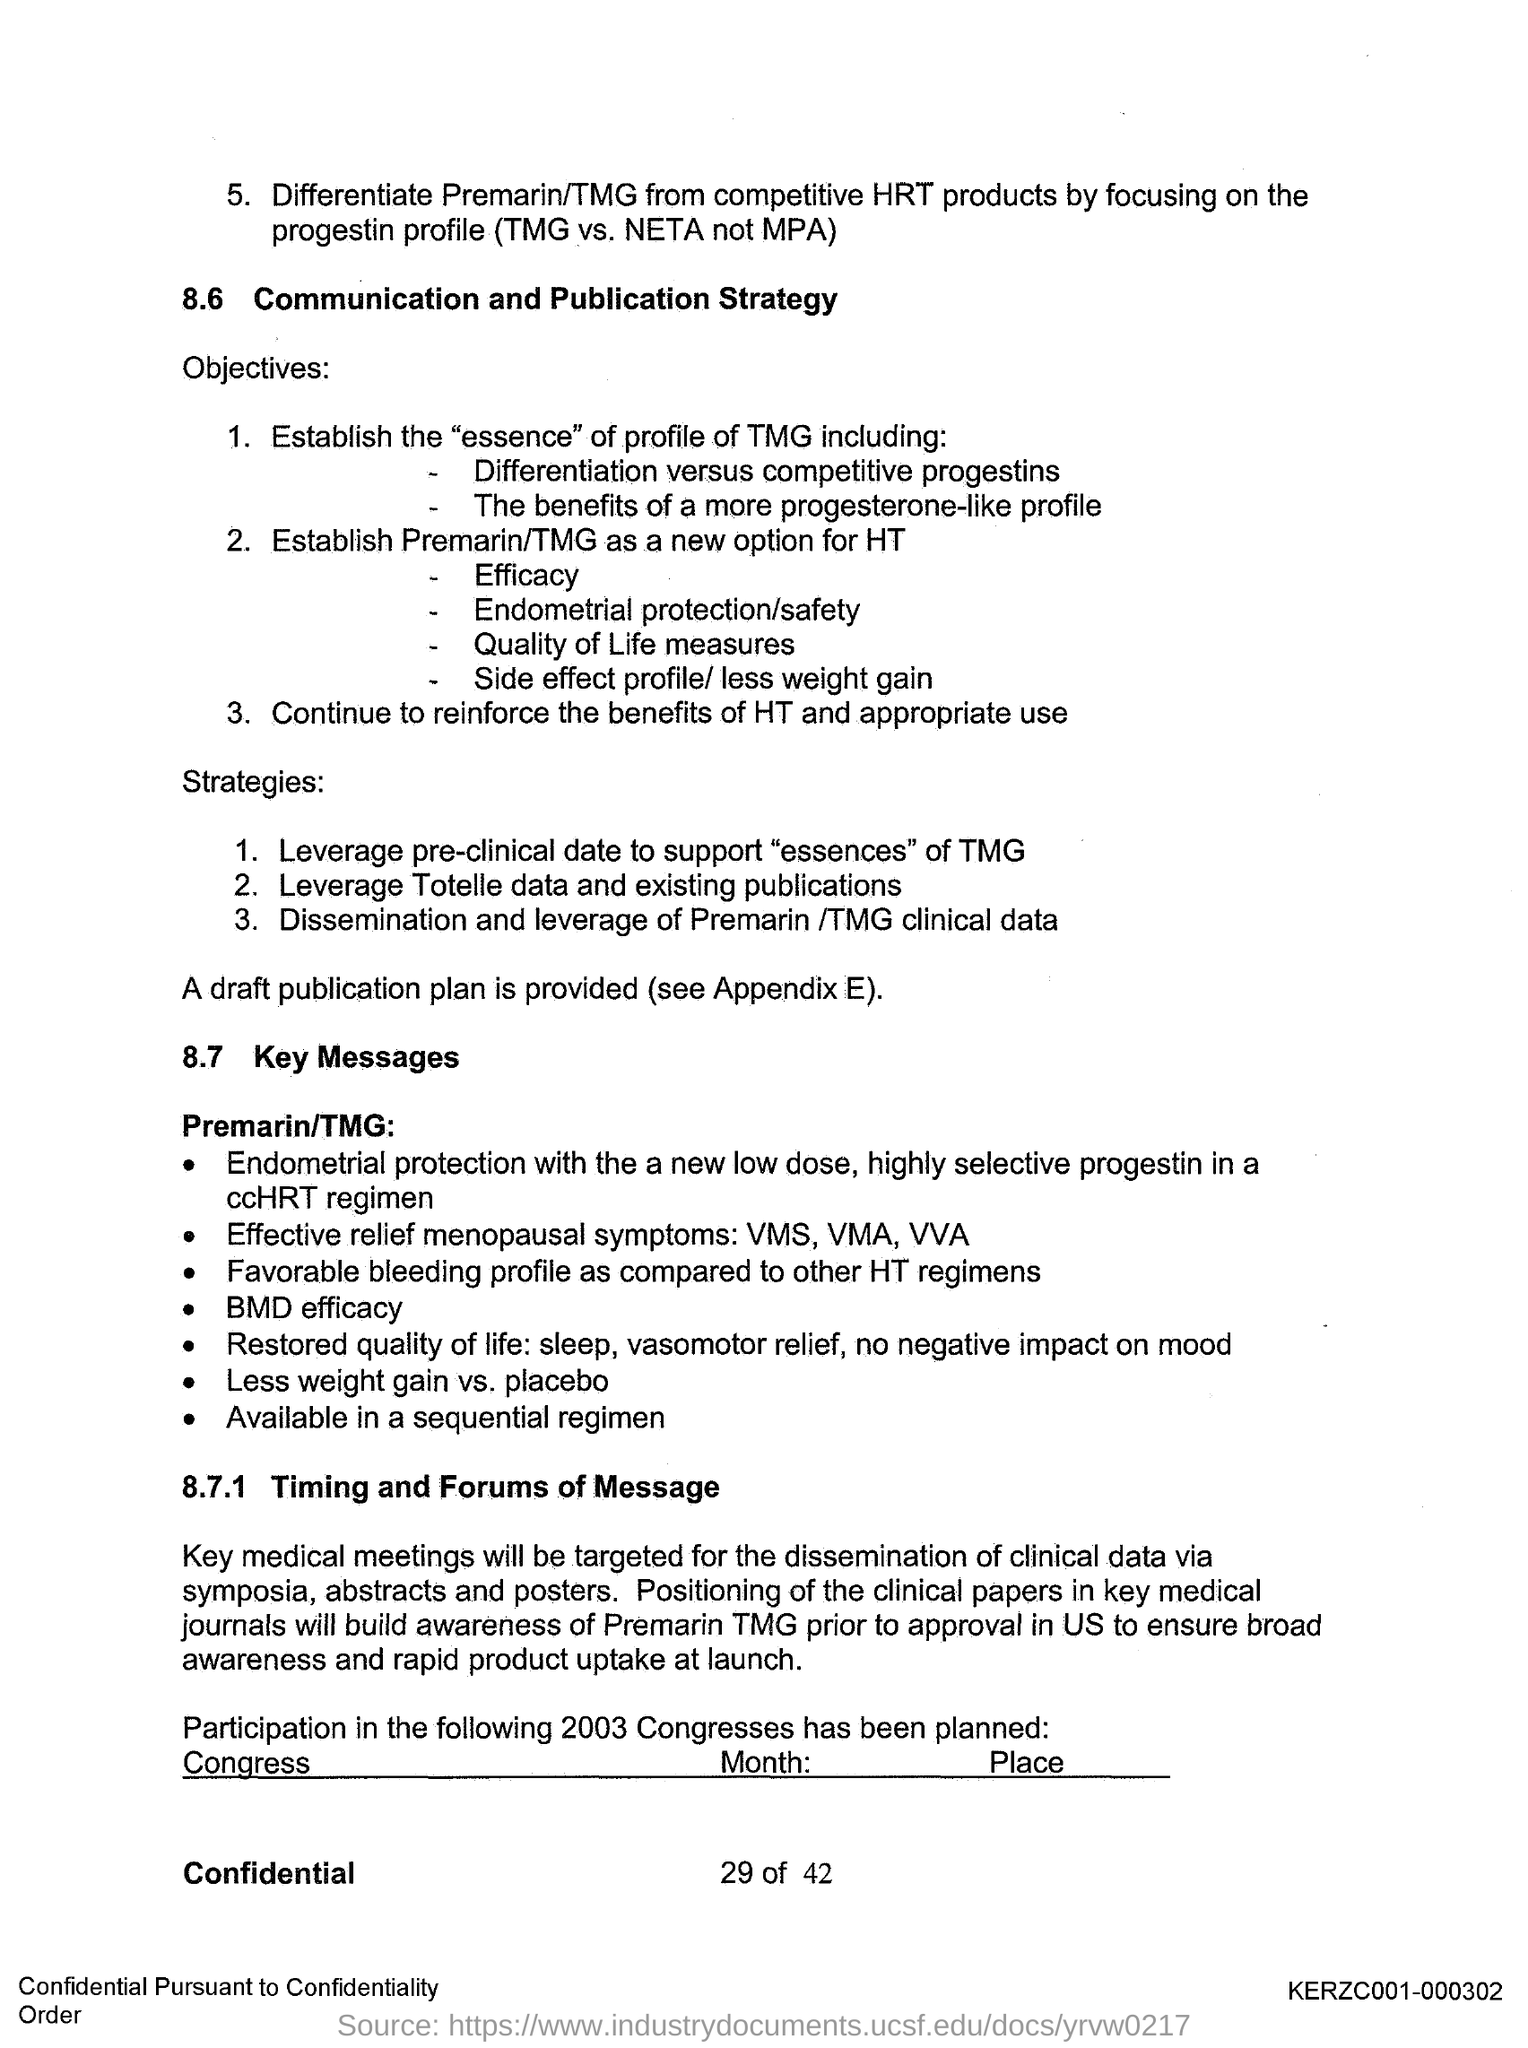What is the first title in the document?
Provide a short and direct response. COMMUNICATION AND PUBLICATION STRATEGY. What is the second title in the document?
Provide a succinct answer. Key Messages. 